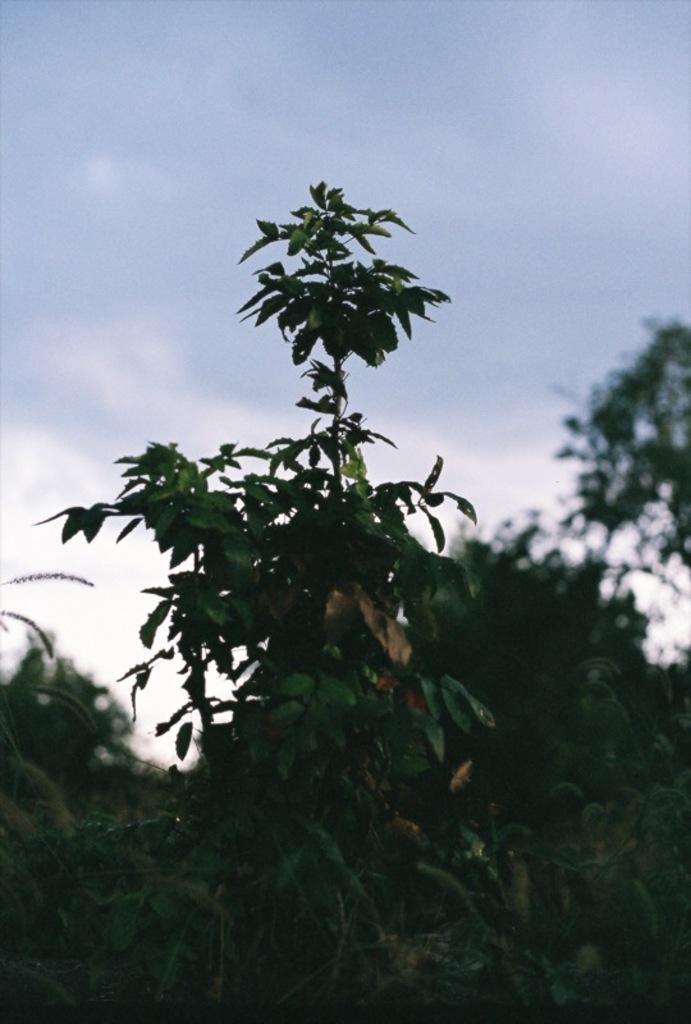In one or two sentences, can you explain what this image depicts? In the middle of the image, there is a tree having green color leaves. In the background, there are trees and there are clouds in the sky. 